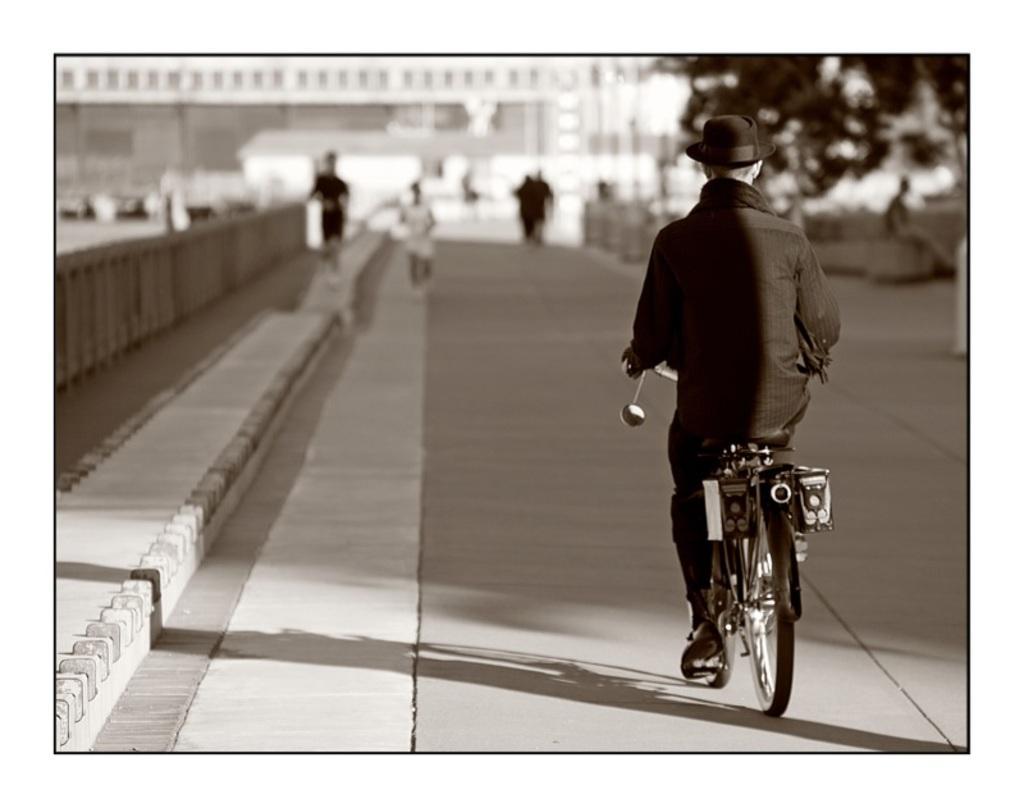Describe this image in one or two sentences. In this image, There is a road in the right side of the image there is a man riding the bicycle which is in black color. 